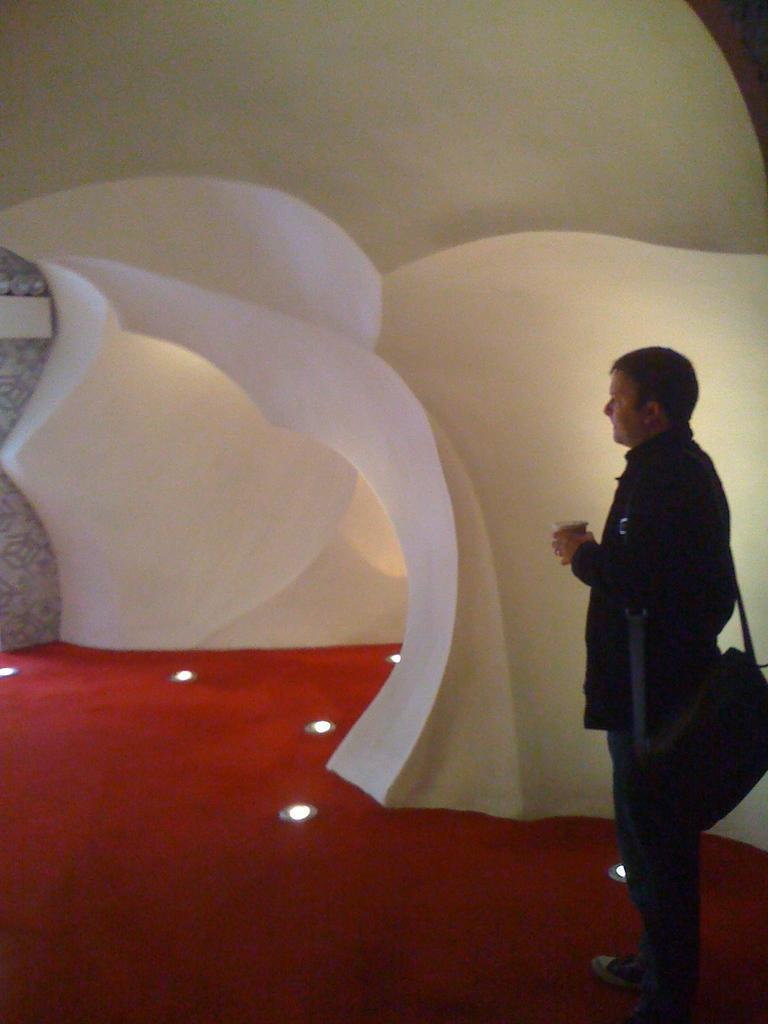Can you describe this image briefly? In this image there is a man standing. He is wearing a bag. He is holding a glass in his hand. In front of him there is a building in the shape of the cave. There are lights on the floor. There is a carpet on the floor. 